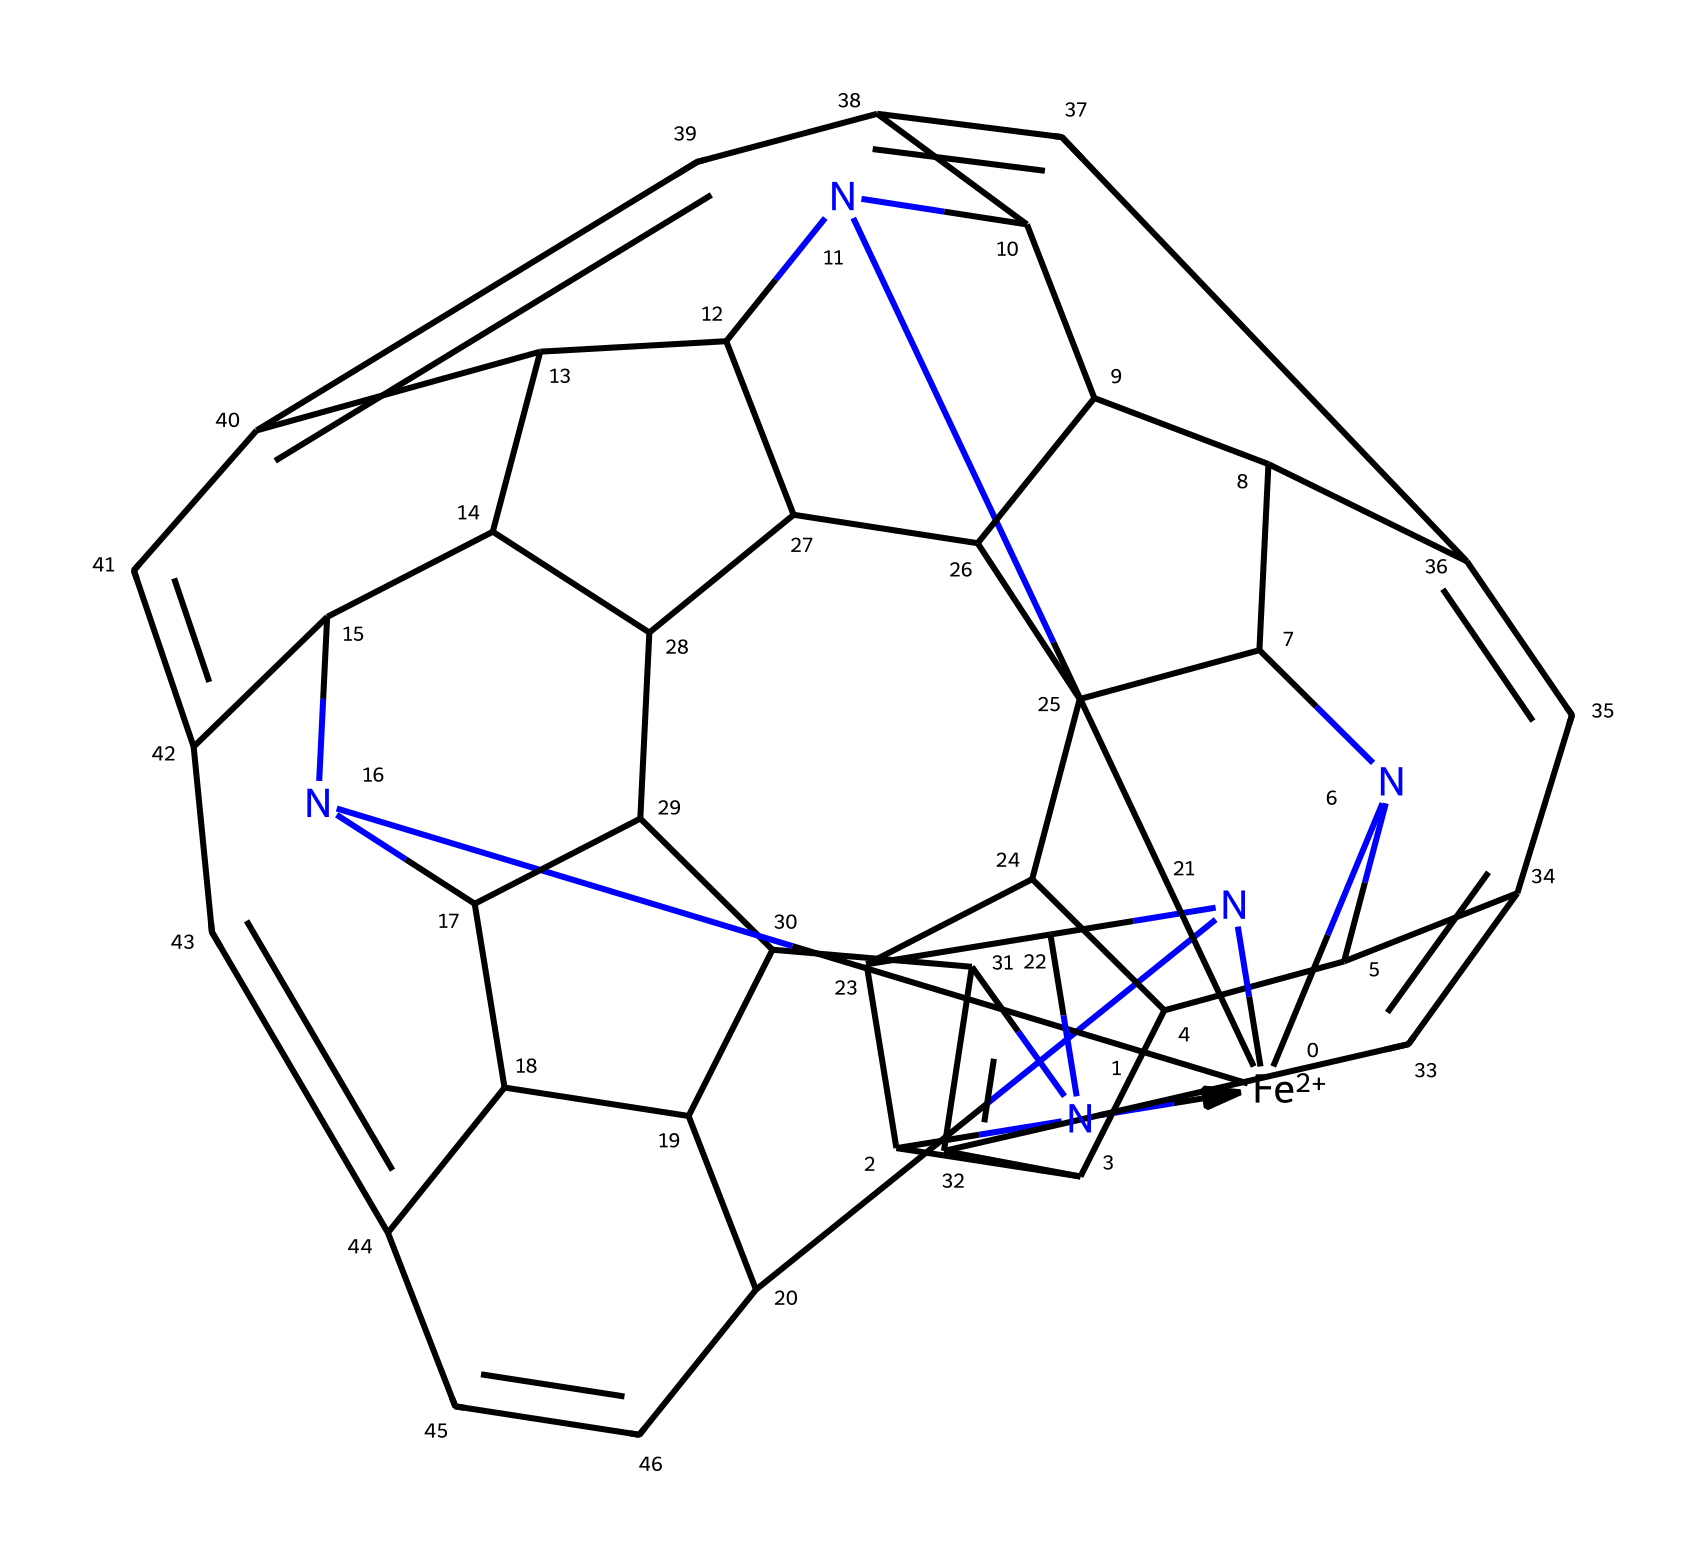What is the central metal ion in this coordination compound? The structure includes an iron ion denoted by [Fe+2], which serves as the central metal in the coordination compound.
Answer: iron How many nitrogen atoms are present in the structure? By examining the SMILES representation, there are five occurrences of nitrogen atoms which can be counted directly.
Answer: five What is the oxidation state of the iron in this complex? The notation [Fe+2] indicates that the iron ion has a +2 oxidation state, which is a typical state in coordination complexes.
Answer: +2 What type of bond primarily forms between the central metal and the nitrogen atoms? In coordination complexes, ligands such as nitrogen typically bind to the central metal ion through coordinate covalent bonds, where the nitrogen donates its lone pair of electrons.
Answer: coordinate covalent bonds How does the coordination environment of iron in hemoglobin affect its function? The presence of ligands, such as nitrogen from histidine residues, creates a unique coordination environment that allows hemoglobin to effectively bind and release oxygen, crucial for its biological function.
Answer: binds oxygen 